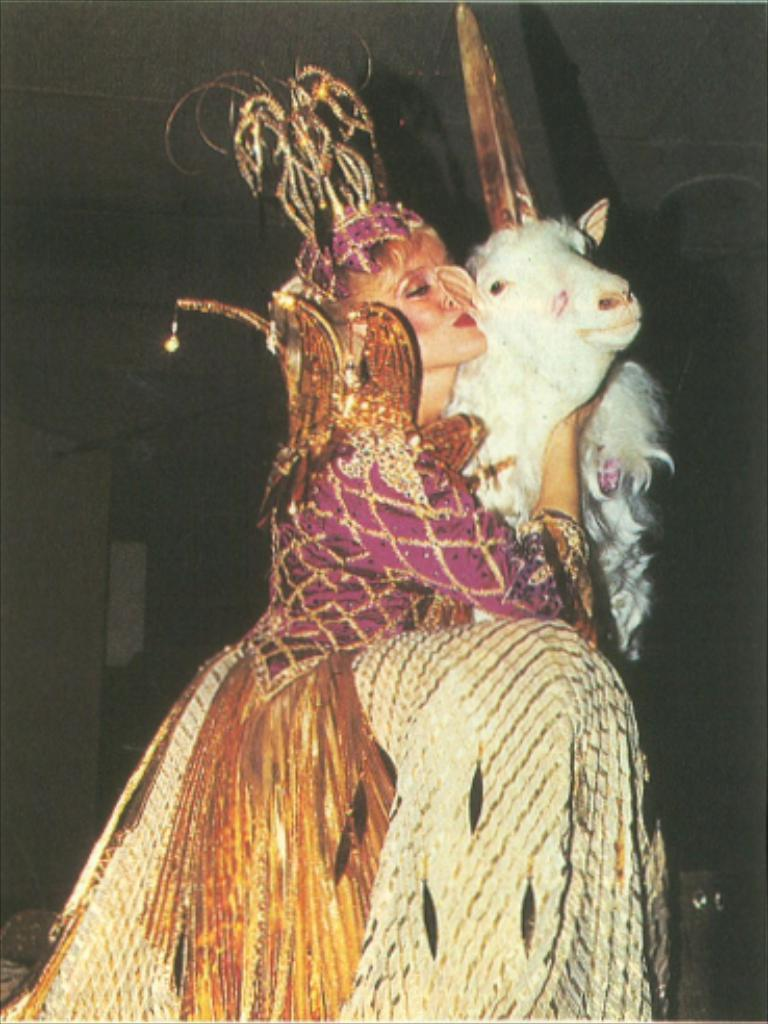Who is the main subject in the image? There is a woman in the center of the image. What is the woman wearing? The woman is wearing a costume. What is the woman holding in the image? The woman is holding a sheep. What can be seen in the background of the image? There are objects in the background of the image. What is visible at the top of the image? There is a ceiling visible at the top of the image. How many toads are present in the image? There are no toads present in the image. What is the range of the afterthought in the image? There is no mention of an afterthought in the image, so it cannot be determined. 